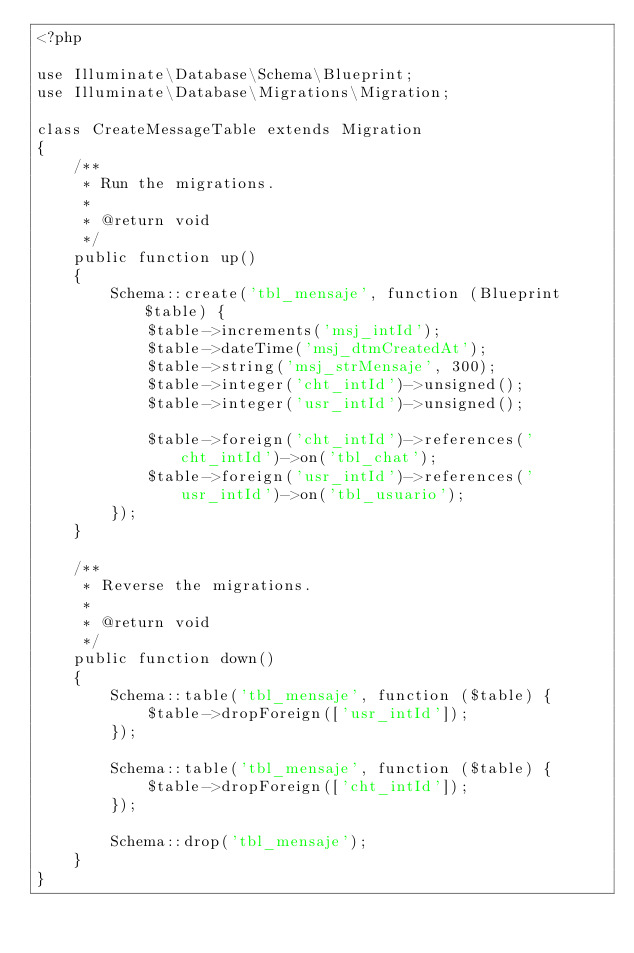Convert code to text. <code><loc_0><loc_0><loc_500><loc_500><_PHP_><?php

use Illuminate\Database\Schema\Blueprint;
use Illuminate\Database\Migrations\Migration;

class CreateMessageTable extends Migration
{
    /**
     * Run the migrations.
     *
     * @return void
     */
    public function up()
    {
        Schema::create('tbl_mensaje', function (Blueprint $table) {
            $table->increments('msj_intId');
            $table->dateTime('msj_dtmCreatedAt');
            $table->string('msj_strMensaje', 300);
            $table->integer('cht_intId')->unsigned();
            $table->integer('usr_intId')->unsigned();
            
            $table->foreign('cht_intId')->references('cht_intId')->on('tbl_chat');
            $table->foreign('usr_intId')->references('usr_intId')->on('tbl_usuario');
        });
    }

    /**
     * Reverse the migrations.
     *
     * @return void
     */
    public function down()
    {
        Schema::table('tbl_mensaje', function ($table) {
            $table->dropForeign(['usr_intId']);
        });

        Schema::table('tbl_mensaje', function ($table) {
            $table->dropForeign(['cht_intId']);
        });

        Schema::drop('tbl_mensaje');
    }
}
</code> 